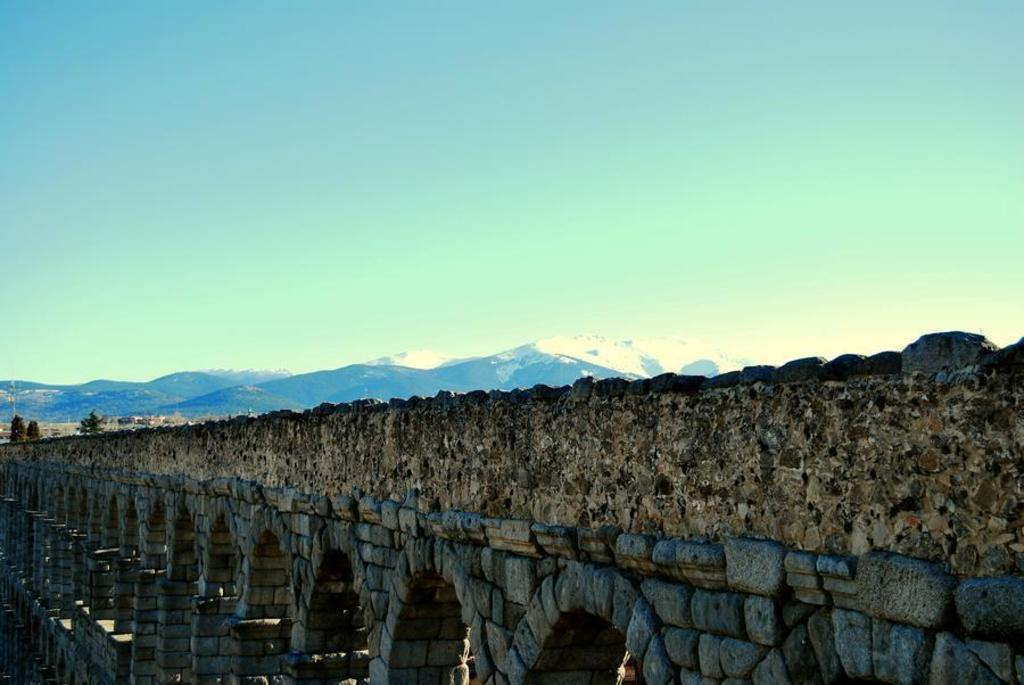What type of structure is visible in the image? There is a fort in the image. What can be seen in the distance behind the fort? There are mountains in the background of the image. What color is the sky in the image? The sky is blue in the image. What type of yard is located near the fort in the image? There is no yard mentioned or visible in the image. 